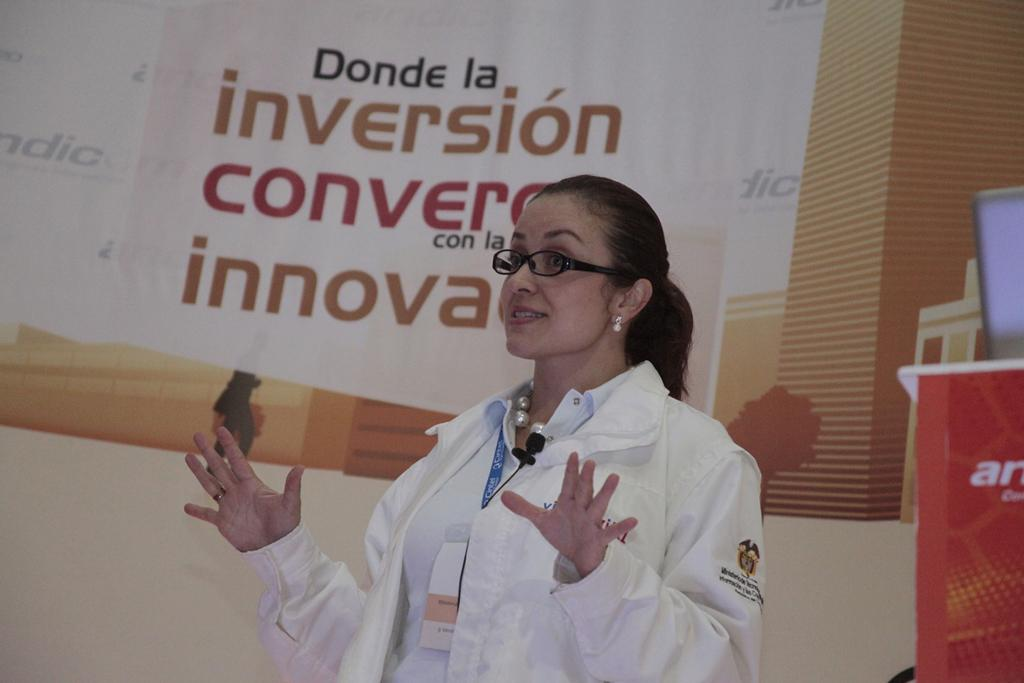What is the woman in the image doing? The woman is standing in the image and smiling. What accessories is the woman wearing? The woman is wearing spectacles, earrings, and a badge. What color is the jacket the woman is wearing? The woman is wearing a white-colored jacket. What type of image is this? The image appears to be a banner. What type of crown is the woman wearing in the image? There is no crown present in the image; the woman is wearing spectacles, earrings, and a badge. How many cherries can be seen on the woman's jacket in the image? There are no cherries visible on the woman's jacket in the image. 